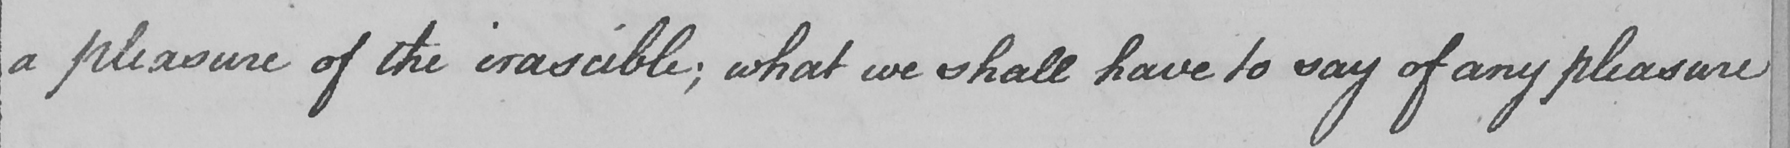Please transcribe the handwritten text in this image. a pleasure of the irascible ; what we shall have to say of any pleasure 